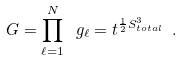Convert formula to latex. <formula><loc_0><loc_0><loc_500><loc_500>G = \prod ^ { N } _ { \ell = 1 } \ g _ { \ell } = t ^ { \frac { 1 } { 2 } S ^ { 3 } _ { t o t a l } } \ .</formula> 